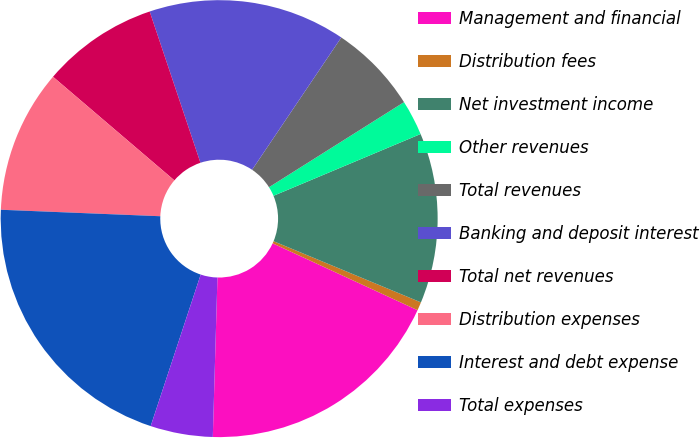Convert chart to OTSL. <chart><loc_0><loc_0><loc_500><loc_500><pie_chart><fcel>Management and financial<fcel>Distribution fees<fcel>Net investment income<fcel>Other revenues<fcel>Total revenues<fcel>Banking and deposit interest<fcel>Total net revenues<fcel>Distribution expenses<fcel>Interest and debt expense<fcel>Total expenses<nl><fcel>18.58%<fcel>0.62%<fcel>12.59%<fcel>2.62%<fcel>6.61%<fcel>14.59%<fcel>8.6%<fcel>10.6%<fcel>20.57%<fcel>4.61%<nl></chart> 